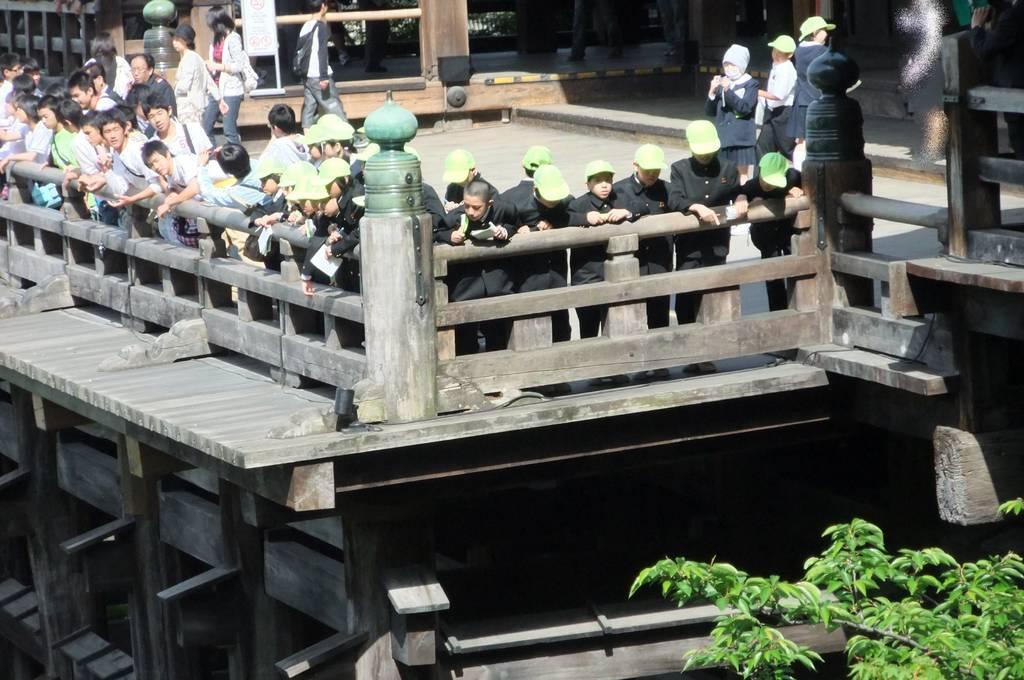Could you give a brief overview of what you see in this image? In this image we can see a wooden boundary, behind the boundary so many people are standing. Right bottom of the image tree is present. 